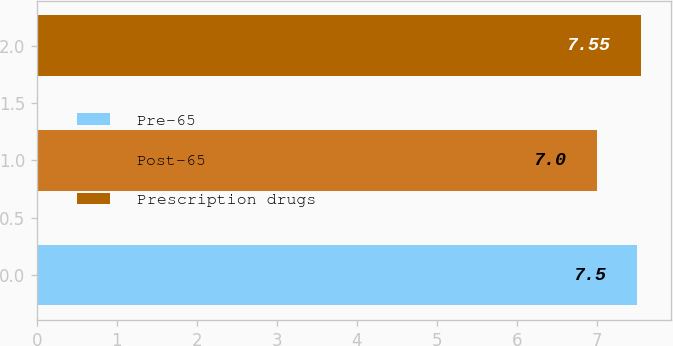Convert chart to OTSL. <chart><loc_0><loc_0><loc_500><loc_500><bar_chart><fcel>Pre-65<fcel>Post-65<fcel>Prescription drugs<nl><fcel>7.5<fcel>7<fcel>7.55<nl></chart> 